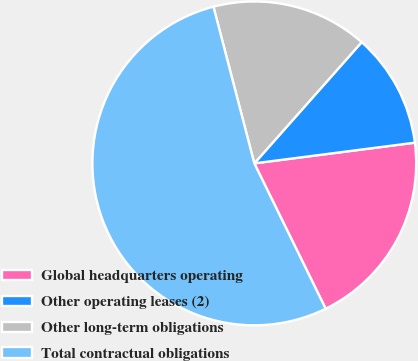Convert chart to OTSL. <chart><loc_0><loc_0><loc_500><loc_500><pie_chart><fcel>Global headquarters operating<fcel>Other operating leases (2)<fcel>Other long-term obligations<fcel>Total contractual obligations<nl><fcel>19.78%<fcel>11.42%<fcel>15.6%<fcel>53.21%<nl></chart> 